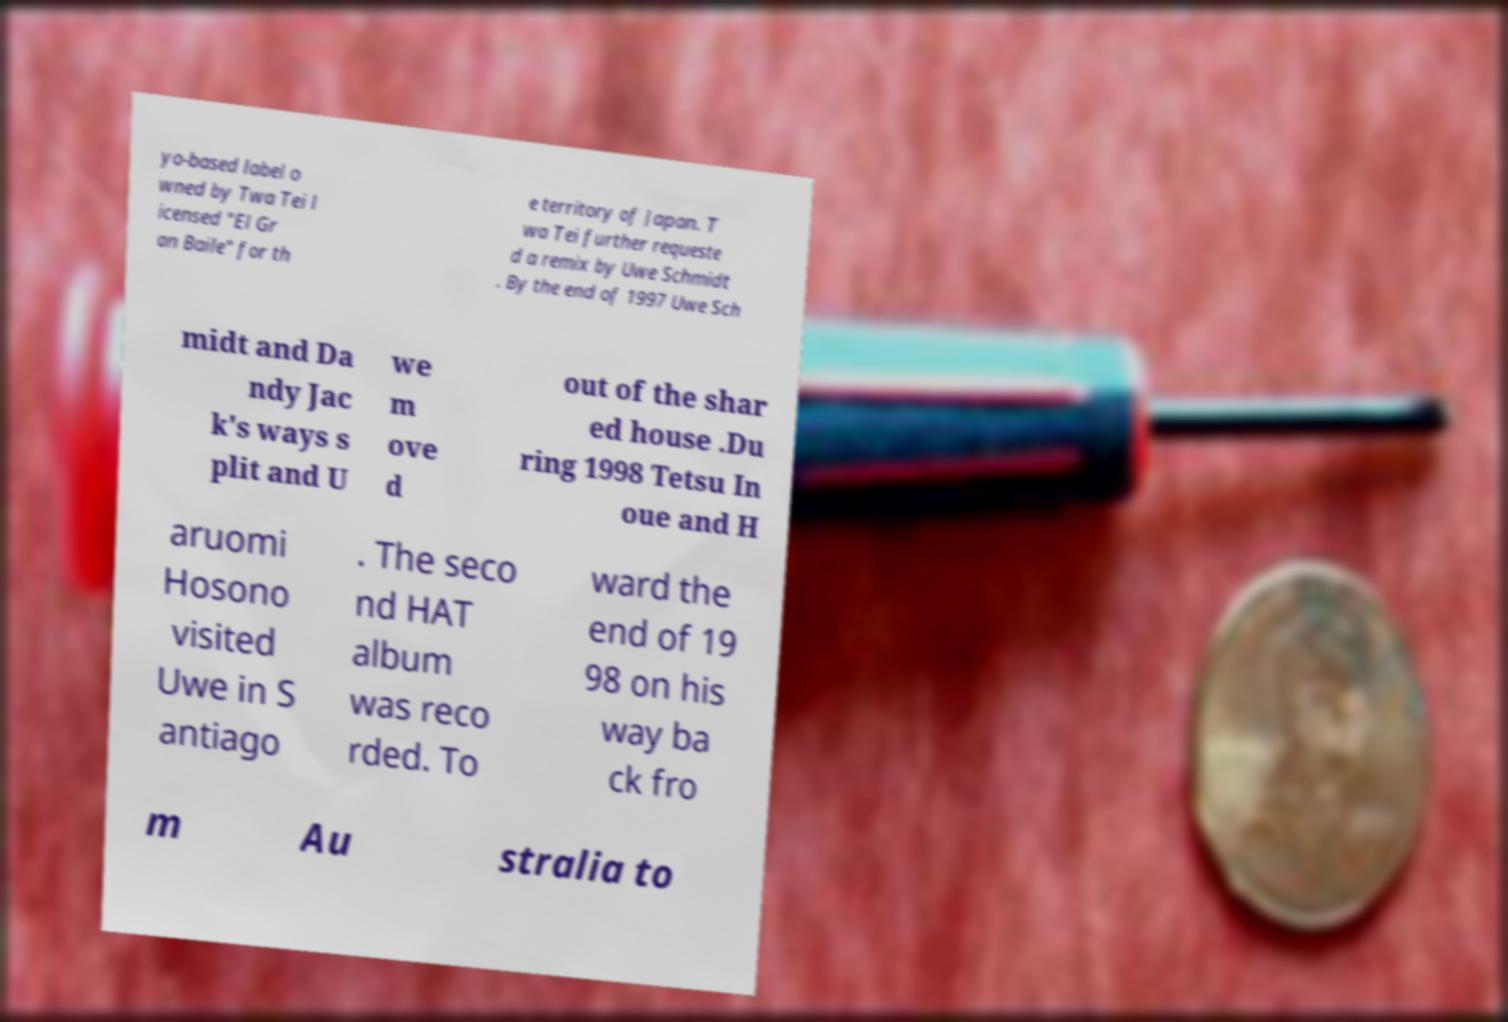For documentation purposes, I need the text within this image transcribed. Could you provide that? yo-based label o wned by Twa Tei l icensed "El Gr an Baile" for th e territory of Japan. T wa Tei further requeste d a remix by Uwe Schmidt . By the end of 1997 Uwe Sch midt and Da ndy Jac k's ways s plit and U we m ove d out of the shar ed house .Du ring 1998 Tetsu In oue and H aruomi Hosono visited Uwe in S antiago . The seco nd HAT album was reco rded. To ward the end of 19 98 on his way ba ck fro m Au stralia to 